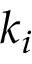<formula> <loc_0><loc_0><loc_500><loc_500>k _ { i }</formula> 